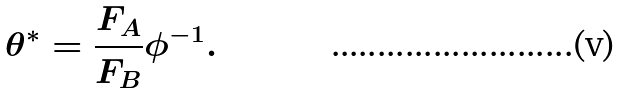Convert formula to latex. <formula><loc_0><loc_0><loc_500><loc_500>\theta ^ { \ast } = \frac { F _ { A } } { F _ { B } } \phi ^ { - 1 } .</formula> 